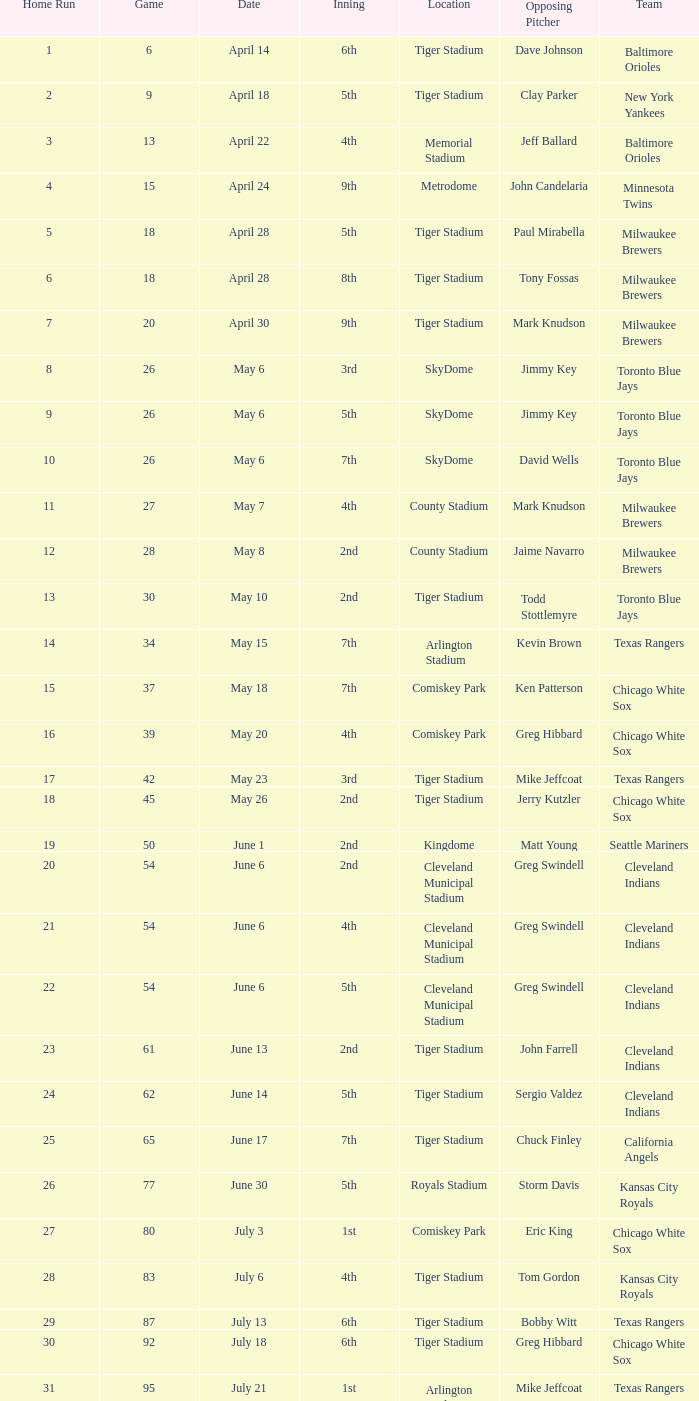What was the date of the game at comiskey park that featured a 4th inning? May 20. 